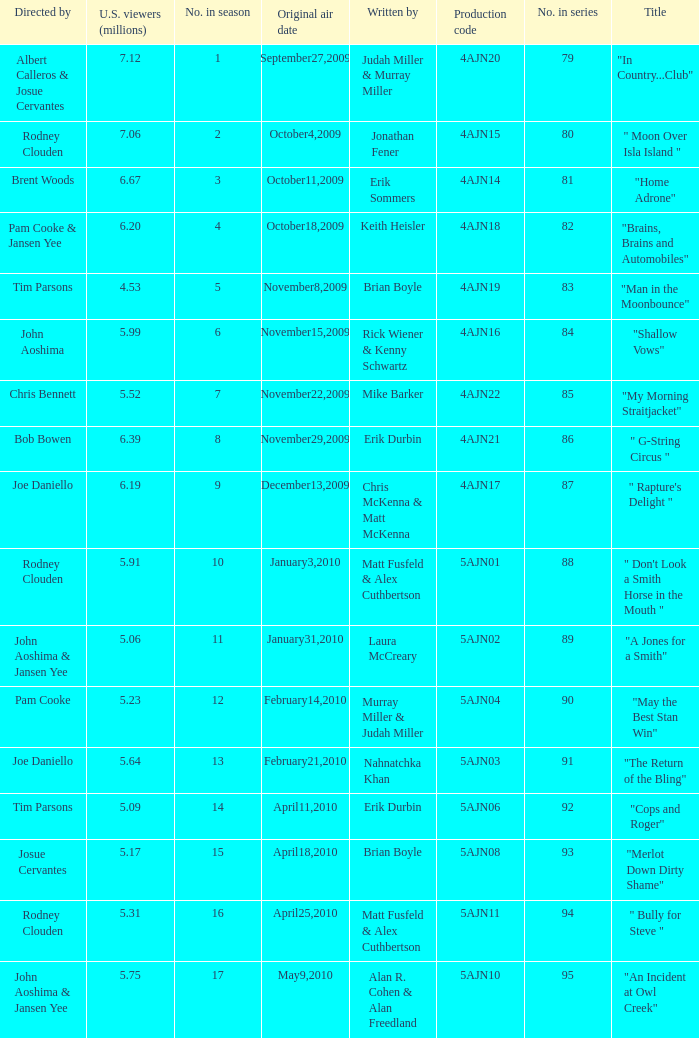Name who wrote 5ajn11 Matt Fusfeld & Alex Cuthbertson. 